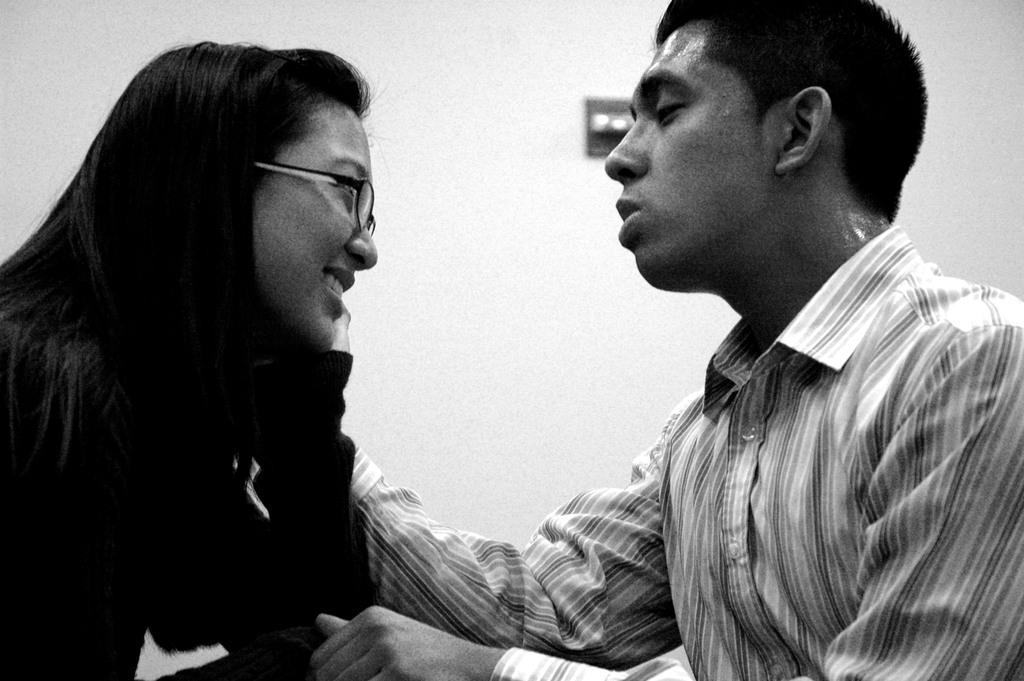In one or two sentences, can you explain what this image depicts? On the right of this picture we can see a person wearing shirt and seems to be sitting. On the left there is a person wearing spectacles, smiling and seems to be sitting. In the background we can see the wall and some other objects. 